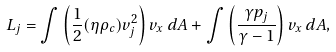<formula> <loc_0><loc_0><loc_500><loc_500>L _ { j } = \int \left ( \frac { 1 } { 2 } ( \eta \rho _ { c } ) v _ { j } ^ { 2 } \right ) v _ { x } \, d A + \int \left ( \frac { \gamma p _ { j } } { \gamma - 1 } \right ) v _ { x } \, d A ,</formula> 